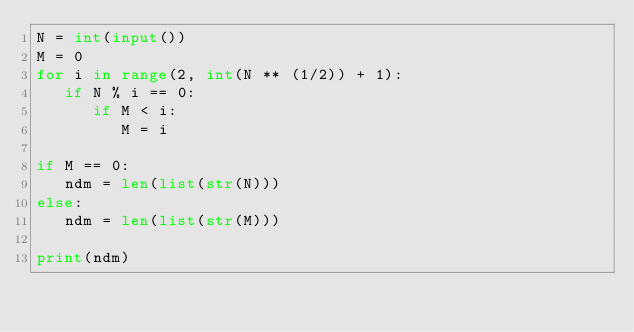<code> <loc_0><loc_0><loc_500><loc_500><_Python_>N = int(input())
M = 0
for i in range(2, int(N ** (1/2)) + 1):
   if N % i == 0:
      if M < i:
         M = i

if M == 0:
   ndm = len(list(str(N)))
else:
   ndm = len(list(str(M)))

print(ndm)</code> 